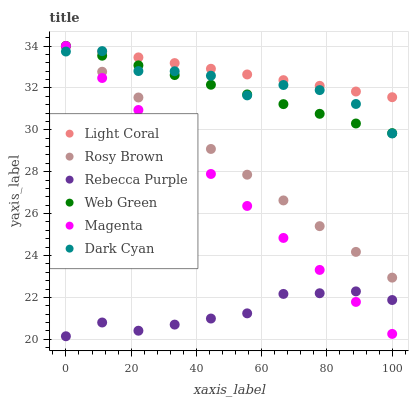Does Rebecca Purple have the minimum area under the curve?
Answer yes or no. Yes. Does Light Coral have the maximum area under the curve?
Answer yes or no. Yes. Does Web Green have the minimum area under the curve?
Answer yes or no. No. Does Web Green have the maximum area under the curve?
Answer yes or no. No. Is Rosy Brown the smoothest?
Answer yes or no. Yes. Is Dark Cyan the roughest?
Answer yes or no. Yes. Is Web Green the smoothest?
Answer yes or no. No. Is Web Green the roughest?
Answer yes or no. No. Does Rebecca Purple have the lowest value?
Answer yes or no. Yes. Does Web Green have the lowest value?
Answer yes or no. No. Does Magenta have the highest value?
Answer yes or no. Yes. Does Rebecca Purple have the highest value?
Answer yes or no. No. Is Rebecca Purple less than Web Green?
Answer yes or no. Yes. Is Light Coral greater than Rebecca Purple?
Answer yes or no. Yes. Does Rosy Brown intersect Magenta?
Answer yes or no. Yes. Is Rosy Brown less than Magenta?
Answer yes or no. No. Is Rosy Brown greater than Magenta?
Answer yes or no. No. Does Rebecca Purple intersect Web Green?
Answer yes or no. No. 